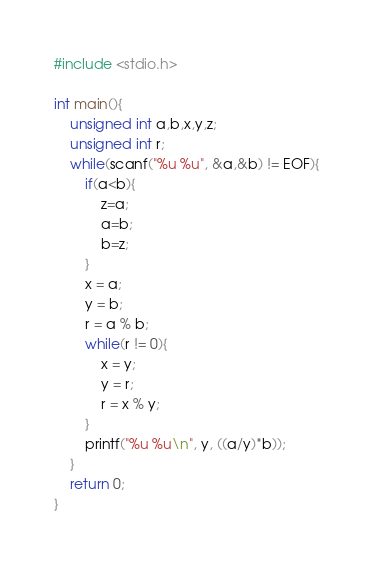<code> <loc_0><loc_0><loc_500><loc_500><_C_>#include <stdio.h>

int main(){
	unsigned int a,b,x,y,z;
	unsigned int r;
	while(scanf("%u %u", &a,&b) != EOF){
		if(a<b){
			z=a;
			a=b;
			b=z;
		}
		x = a;
		y = b;
		r = a % b;
		while(r != 0){
			x = y;
			y = r;
			r = x % y;
		}
		printf("%u %u\n", y, ((a/y)*b));
	}
	return 0;
}</code> 